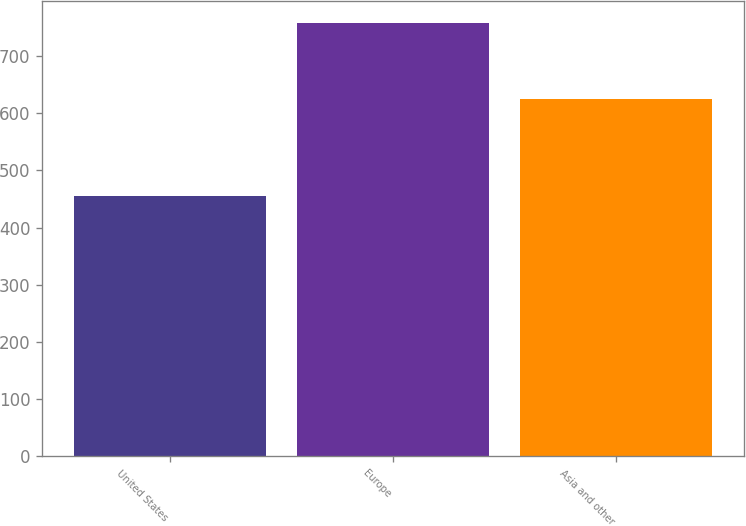Convert chart to OTSL. <chart><loc_0><loc_0><loc_500><loc_500><bar_chart><fcel>United States<fcel>Europe<fcel>Asia and other<nl><fcel>455<fcel>758<fcel>624<nl></chart> 